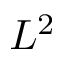Convert formula to latex. <formula><loc_0><loc_0><loc_500><loc_500>L ^ { 2 }</formula> 